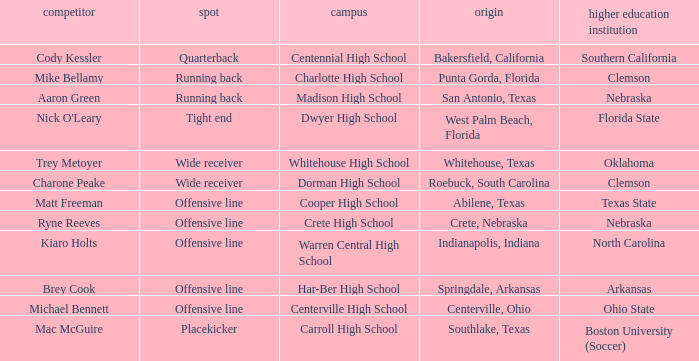What was the position of the player that went to warren central high school? Offensive line. 